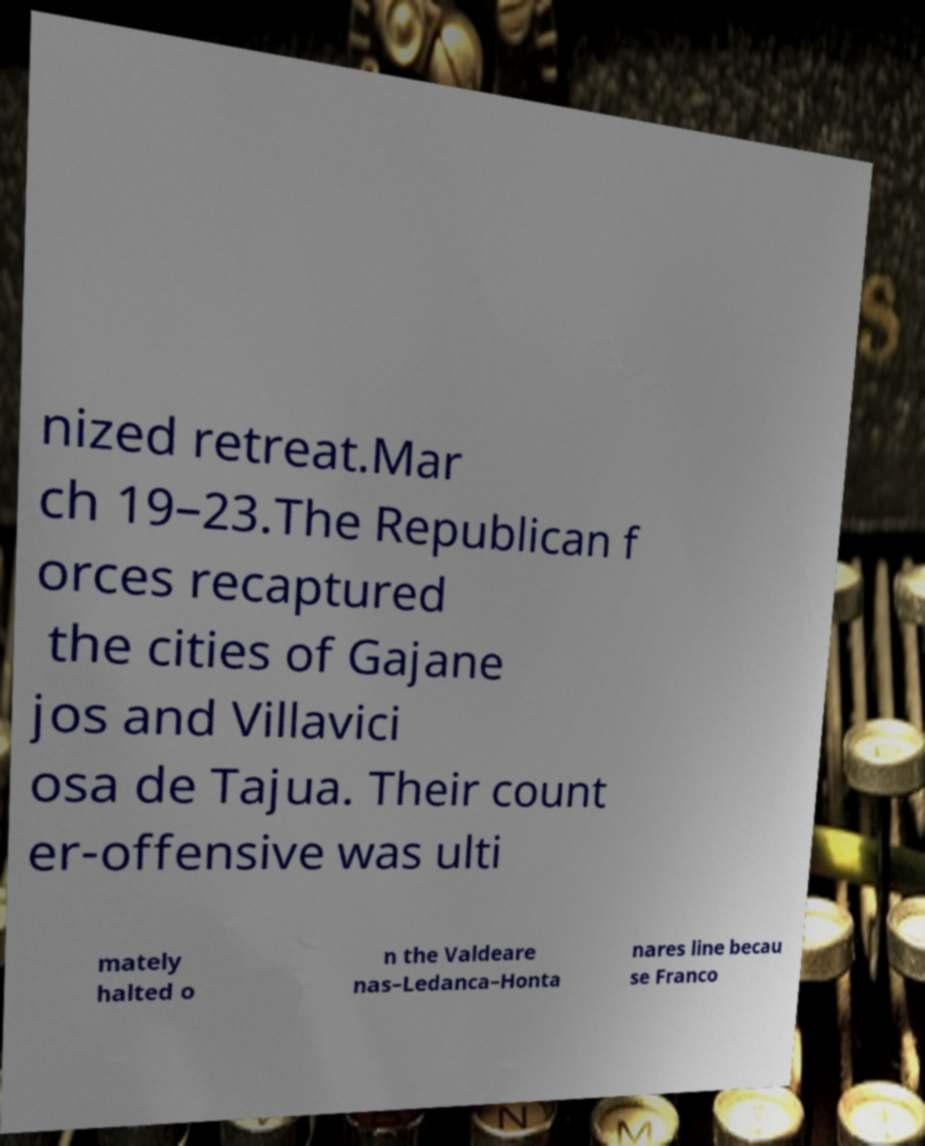What messages or text are displayed in this image? I need them in a readable, typed format. nized retreat.Mar ch 19–23.The Republican f orces recaptured the cities of Gajane jos and Villavici osa de Tajua. Their count er-offensive was ulti mately halted o n the Valdeare nas–Ledanca–Honta nares line becau se Franco 